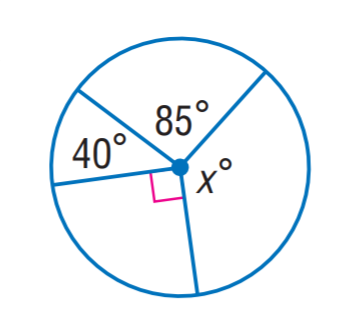Answer the mathemtical geometry problem and directly provide the correct option letter.
Question: Find x.
Choices: A: 95 B: 120 C: 140 D: 145 D 